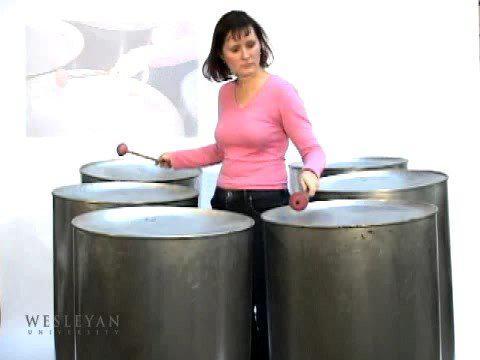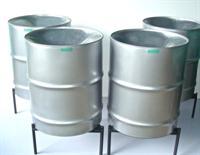The first image is the image on the left, the second image is the image on the right. Assess this claim about the two images: "The right image shows a pair of pink-tipped drumsticks resting on top of the middle of three upright black barrels, which stand in front of three non-upright black barrels.". Correct or not? Answer yes or no. No. The first image is the image on the left, the second image is the image on the right. Analyze the images presented: Is the assertion "There is one image that includes fewer than six drums." valid? Answer yes or no. Yes. 